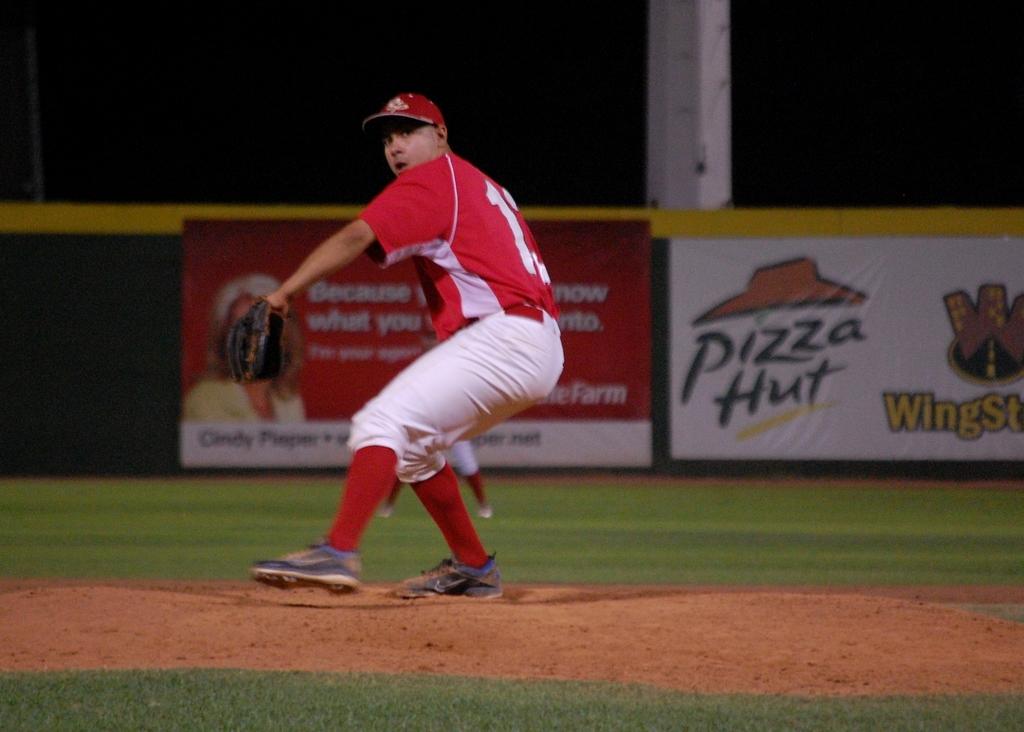What pizza company is on the right sign?
Offer a terse response. Pizza hut. What st is at pizza hut?
Provide a succinct answer. Wing. 